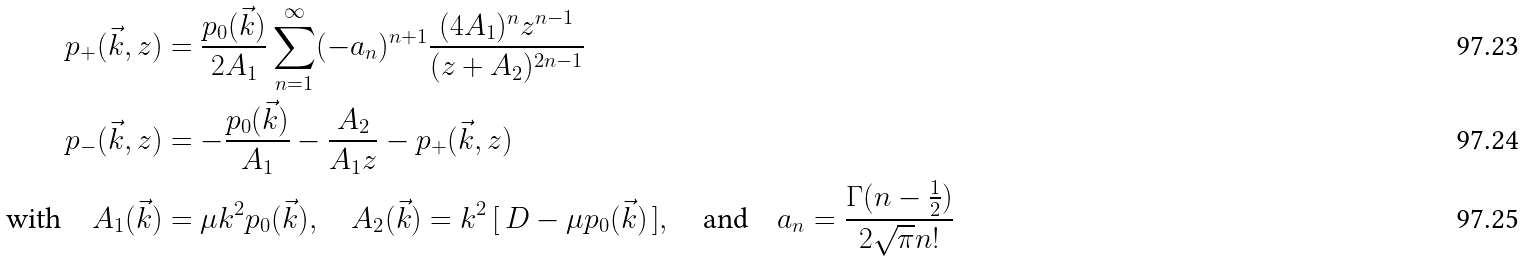Convert formula to latex. <formula><loc_0><loc_0><loc_500><loc_500>p _ { + } ( \vec { k } , z ) & = \frac { p _ { 0 } ( \vec { k } ) } { 2 A _ { 1 } } \sum _ { n = 1 } ^ { \infty } ( - a _ { n } ) ^ { n + 1 } \frac { ( 4 A _ { 1 } ) ^ { n } z ^ { n - 1 } } { ( z + A _ { 2 } ) ^ { 2 n - 1 } } \\ p _ { - } ( \vec { k } , z ) & = - \frac { p _ { 0 } ( \vec { k } ) } { A _ { 1 } } - \frac { A _ { 2 } } { A _ { 1 } z } - p _ { + } ( \vec { k } , z ) \\ \text {with} \quad A _ { 1 } ( \vec { k } ) & = \mu k ^ { 2 } p _ { 0 } ( \vec { k } ) , \quad A _ { 2 } ( \vec { k } ) = k ^ { 2 } \, [ \, D - \mu p _ { 0 } ( \vec { k } ) \, ] , \quad \text {and} \quad a _ { n } = \frac { \Gamma ( n - \frac { 1 } { 2 } ) } { 2 \sqrt { \pi } n ! }</formula> 